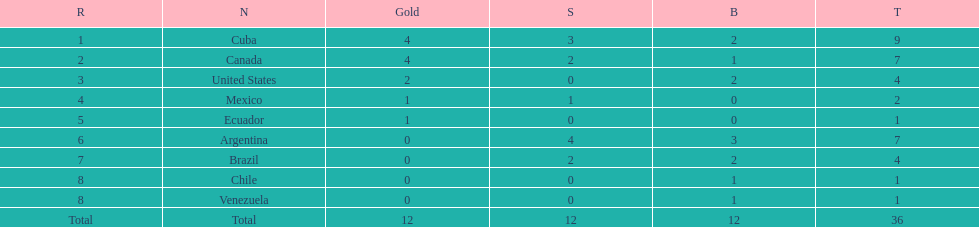Which nations participated? Cuba, Canada, United States, Mexico, Ecuador, Argentina, Brazil, Chile, Venezuela. Which nations won gold? Cuba, Canada, United States, Mexico, Ecuador. Which nations did not win silver? United States, Ecuador, Chile, Venezuela. Out of those countries previously listed, which nation won gold? United States. 